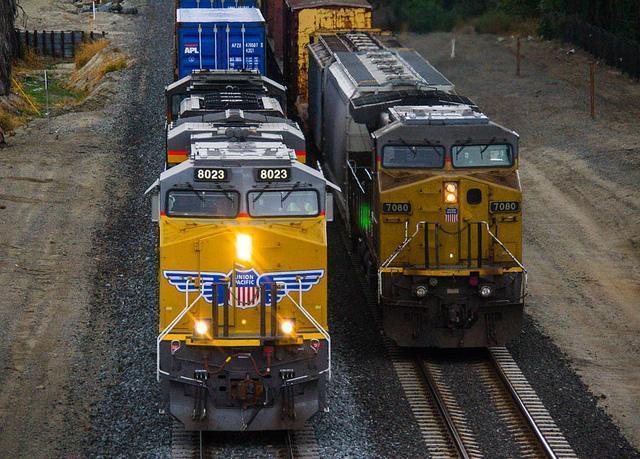How many trains are shown?
Give a very brief answer. 2. How many trains can be seen?
Give a very brief answer. 2. How many red umbrellas do you see?
Give a very brief answer. 0. 